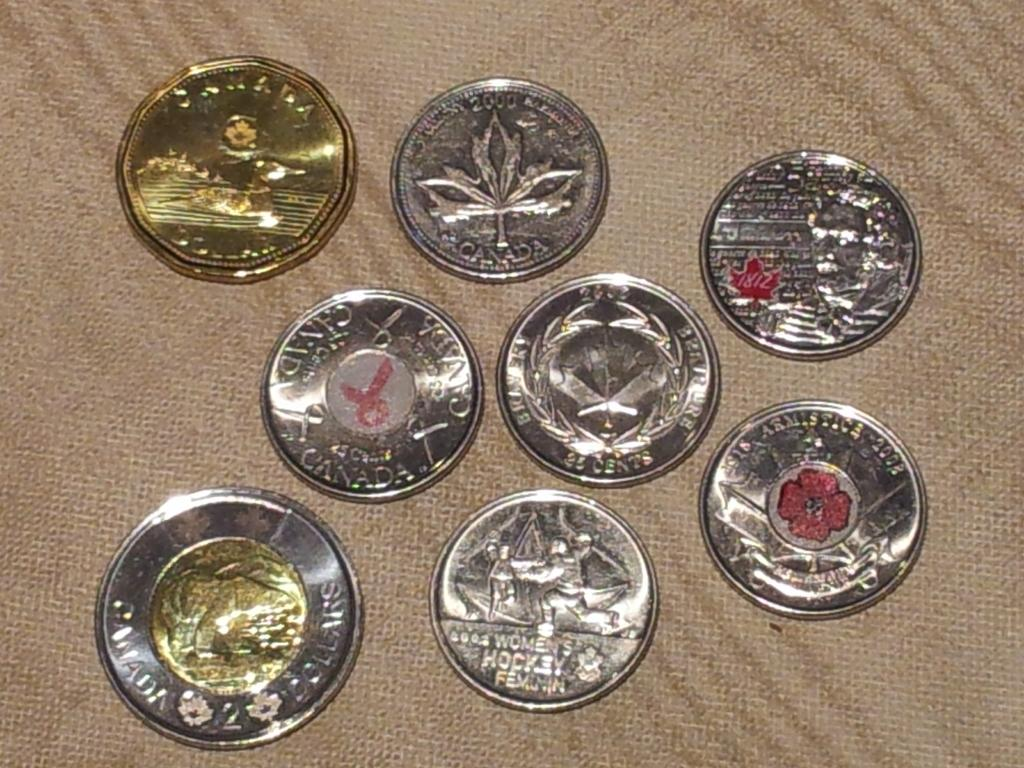<image>
Create a compact narrative representing the image presented. 8 coins lie on a piece of material and one from Canada has a red ribbon in the middle. 